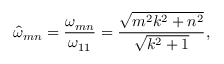Convert formula to latex. <formula><loc_0><loc_0><loc_500><loc_500>\hat { \omega } _ { m n } = \frac { \omega _ { m n } } { \omega _ { 1 1 } } = \frac { \sqrt { m ^ { 2 } k ^ { 2 } + n ^ { 2 } } } { \sqrt { k ^ { 2 } + 1 } } ,</formula> 